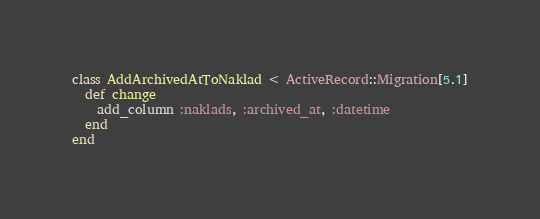Convert code to text. <code><loc_0><loc_0><loc_500><loc_500><_Ruby_>class AddArchivedAtToNaklad < ActiveRecord::Migration[5.1]
  def change
    add_column :naklads, :archived_at, :datetime
  end
end
</code> 